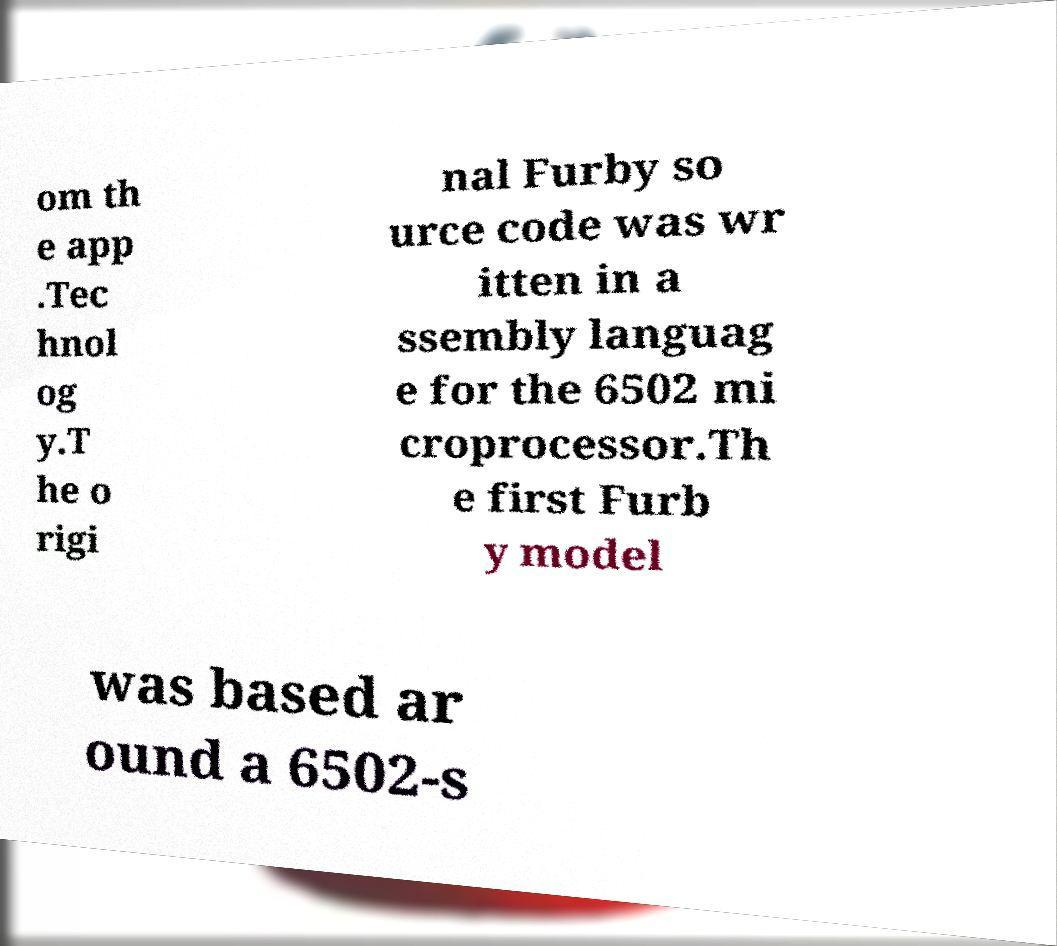Could you extract and type out the text from this image? om th e app .Tec hnol og y.T he o rigi nal Furby so urce code was wr itten in a ssembly languag e for the 6502 mi croprocessor.Th e first Furb y model was based ar ound a 6502-s 